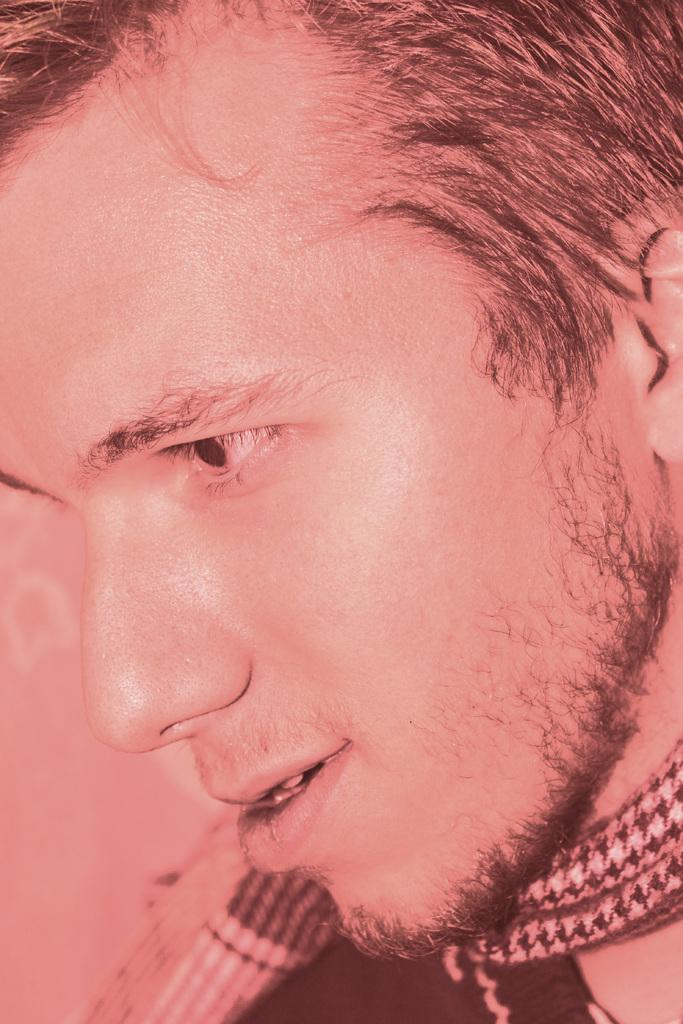Who is present in the image? There is a man in the image. What is the man wearing? The man is wearing a black dress. In which direction is the man looking? The man is looking towards the left side. What type of accessory is visible on the man? There is a neck ware visible on the man. What type of magic is the man performing in the image? There is no indication of magic or any magical activity in the image. 